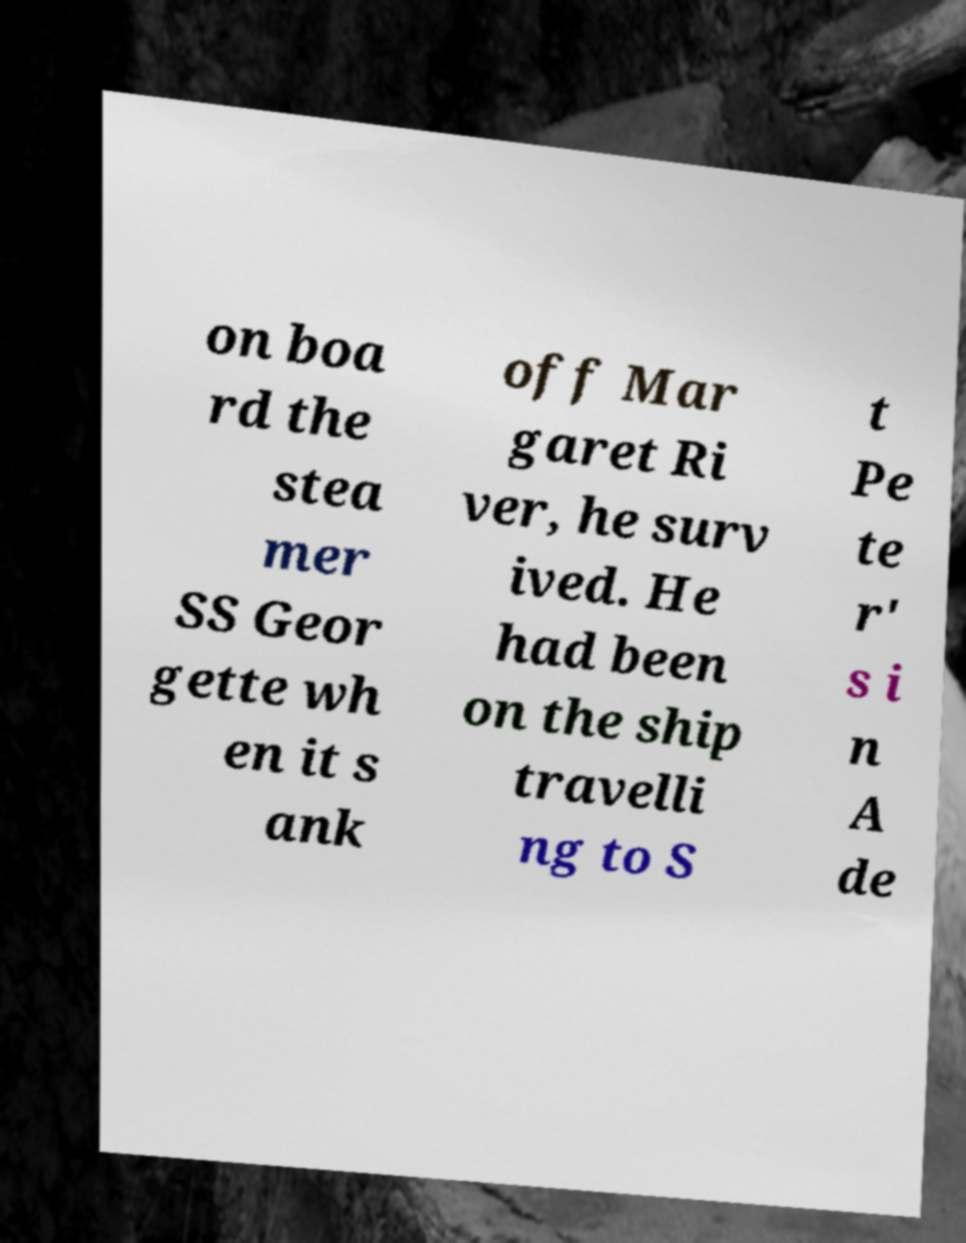Could you assist in decoding the text presented in this image and type it out clearly? on boa rd the stea mer SS Geor gette wh en it s ank off Mar garet Ri ver, he surv ived. He had been on the ship travelli ng to S t Pe te r' s i n A de 